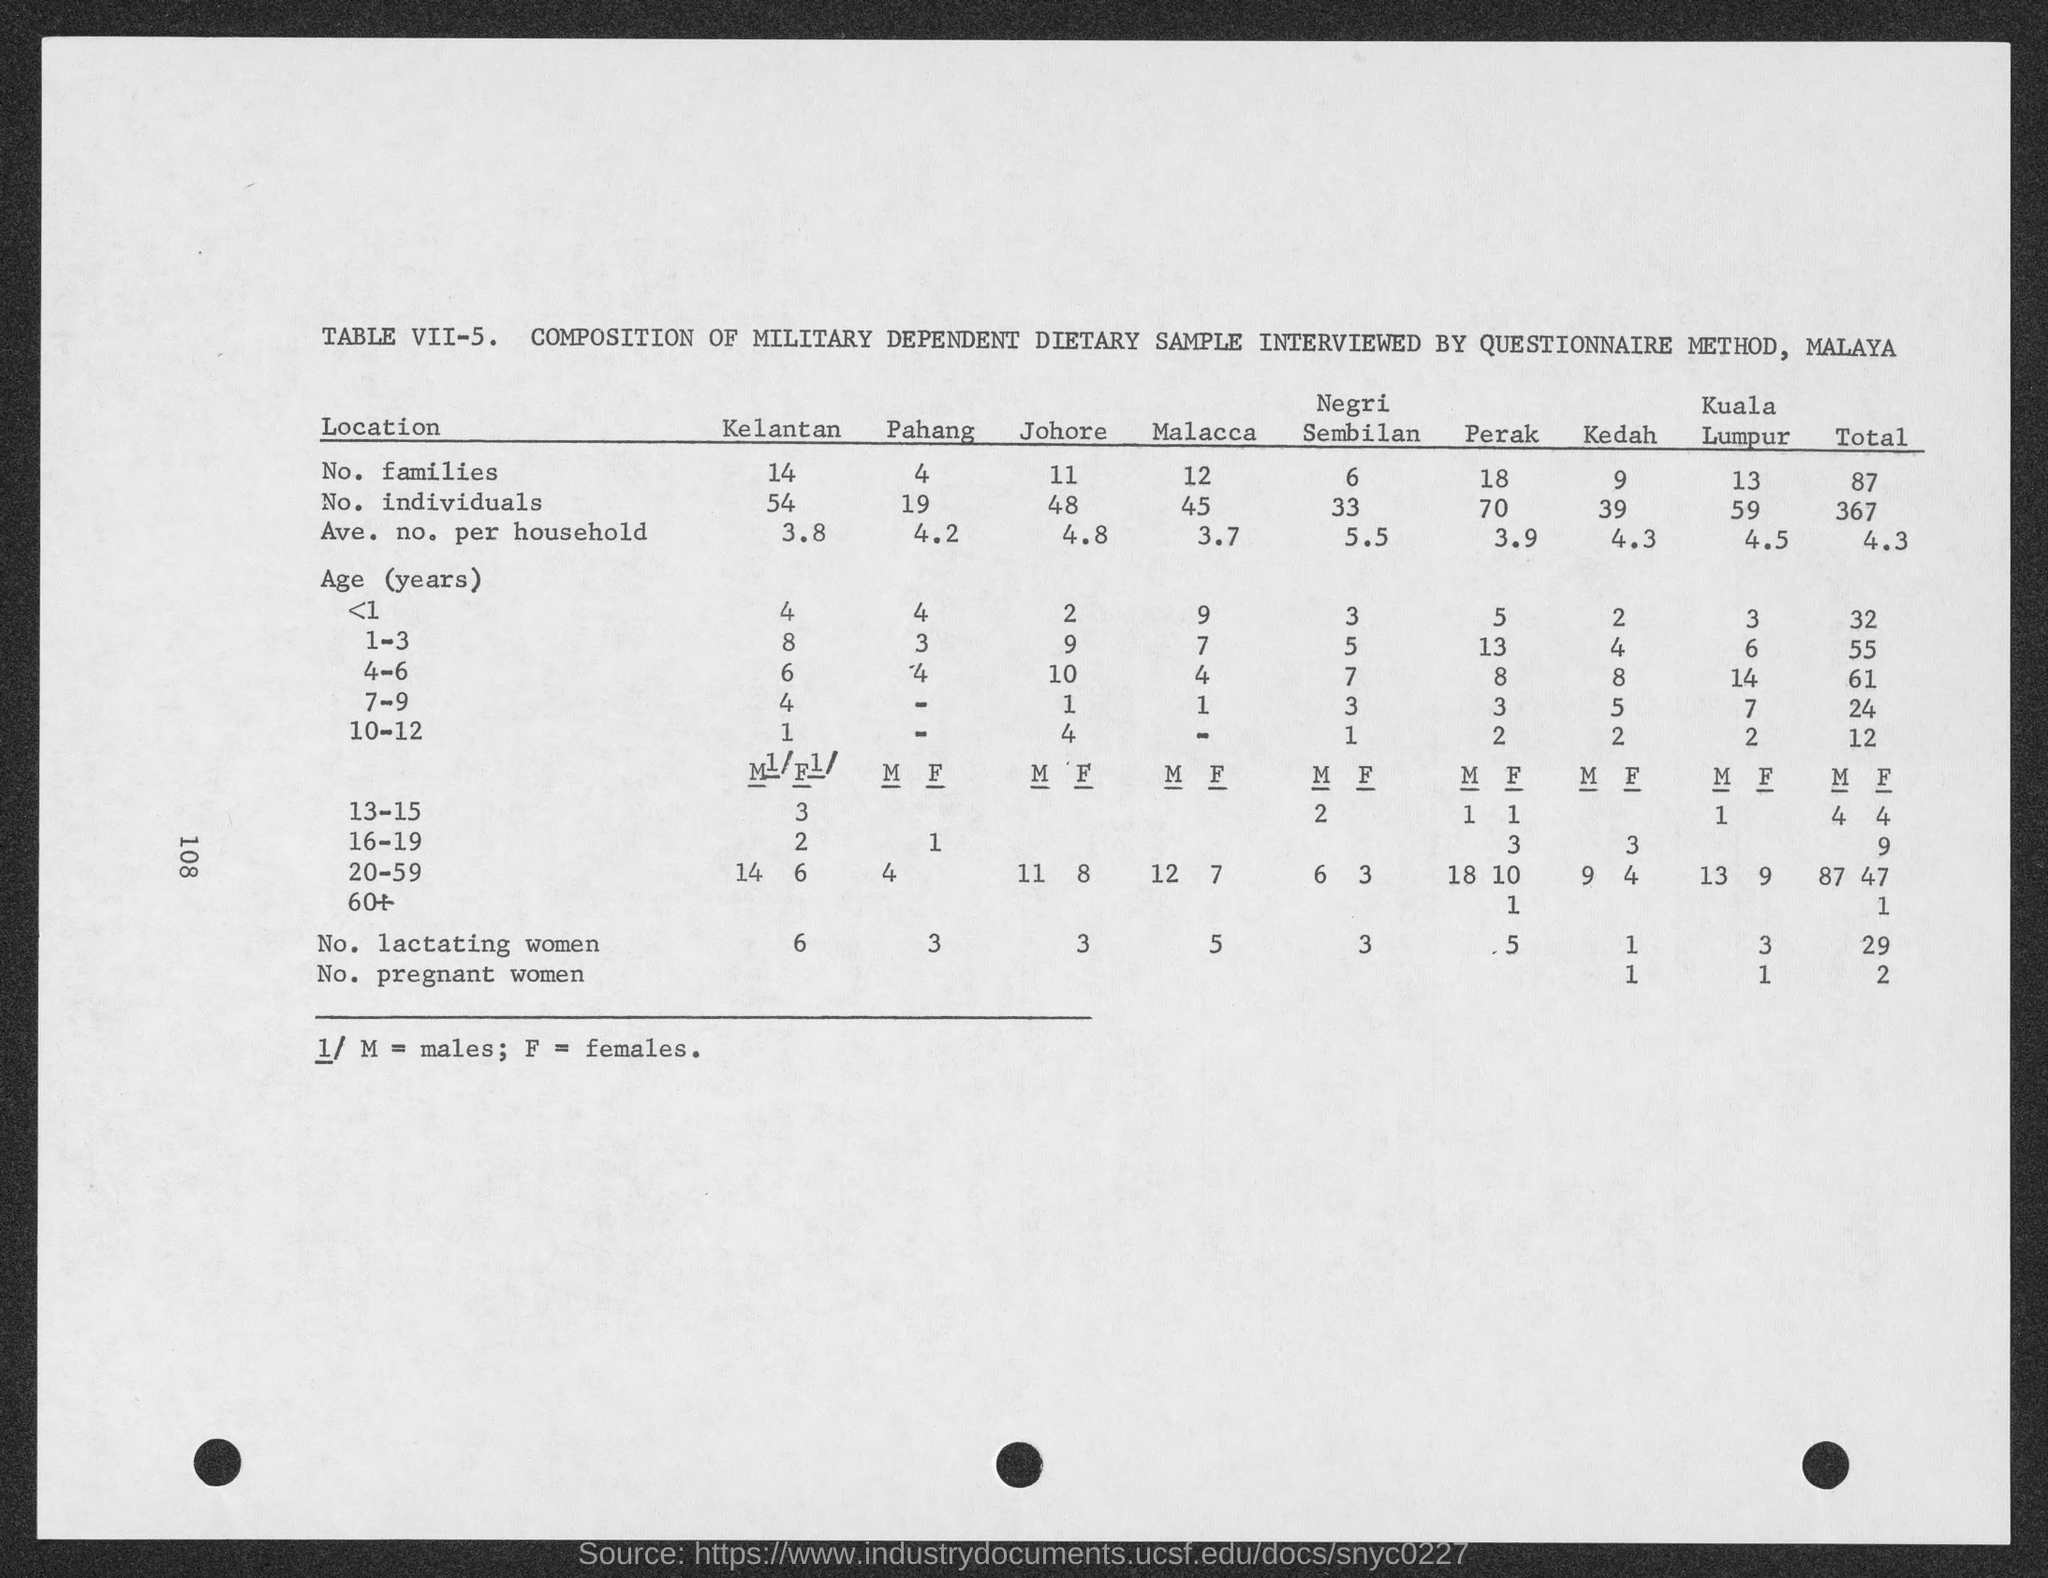what is the no. of individuals in Pahang? According to the document in the image, there were 19 individuals in the Pahang location that were part of a military dependent dietary sample interviewed by a questionnaire method in Malaya. 